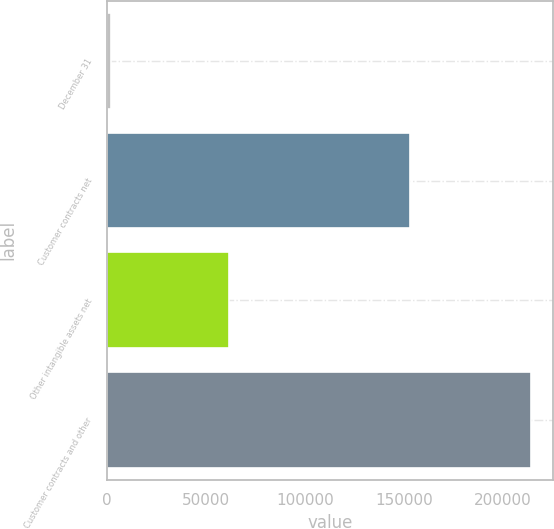<chart> <loc_0><loc_0><loc_500><loc_500><bar_chart><fcel>December 31<fcel>Customer contracts net<fcel>Other intangible assets net<fcel>Customer contracts and other<nl><fcel>2017<fcel>152869<fcel>61548<fcel>214417<nl></chart> 